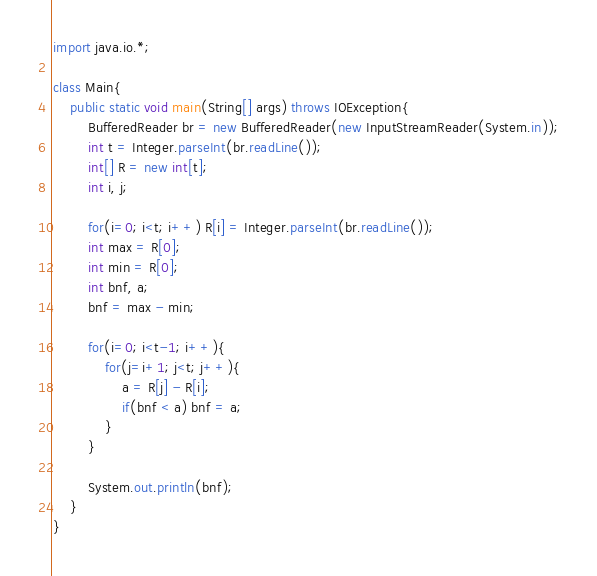<code> <loc_0><loc_0><loc_500><loc_500><_Java_>import java.io.*;
            
class Main{
    public static void main(String[] args) throws IOException{
        BufferedReader br = new BufferedReader(new InputStreamReader(System.in));
        int t = Integer.parseInt(br.readLine());
        int[] R = new int[t];
        int i, j;
            
        for(i=0; i<t; i++) R[i] = Integer.parseInt(br.readLine());
        int max = R[0];
        int min = R[0];
        int bnf, a;
        bnf = max - min;
            
        for(i=0; i<t-1; i++){
            for(j=i+1; j<t; j++){
                a = R[j] - R[i];
                if(bnf < a) bnf = a;
            }
        }
             
        System.out.println(bnf);
    }
}</code> 